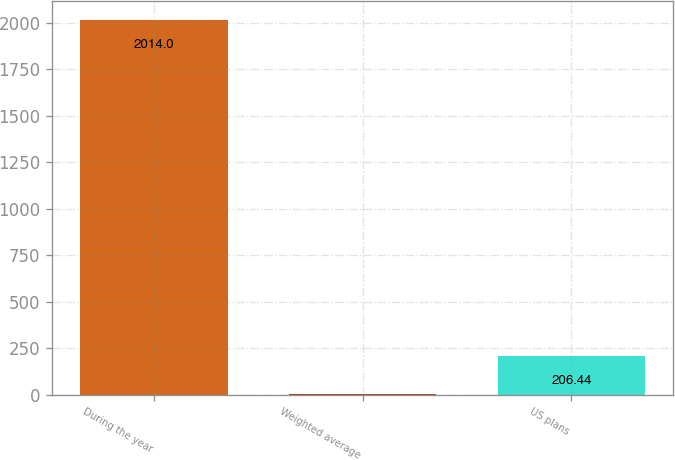Convert chart. <chart><loc_0><loc_0><loc_500><loc_500><bar_chart><fcel>During the year<fcel>Weighted average<fcel>US plans<nl><fcel>2014<fcel>5.6<fcel>206.44<nl></chart> 